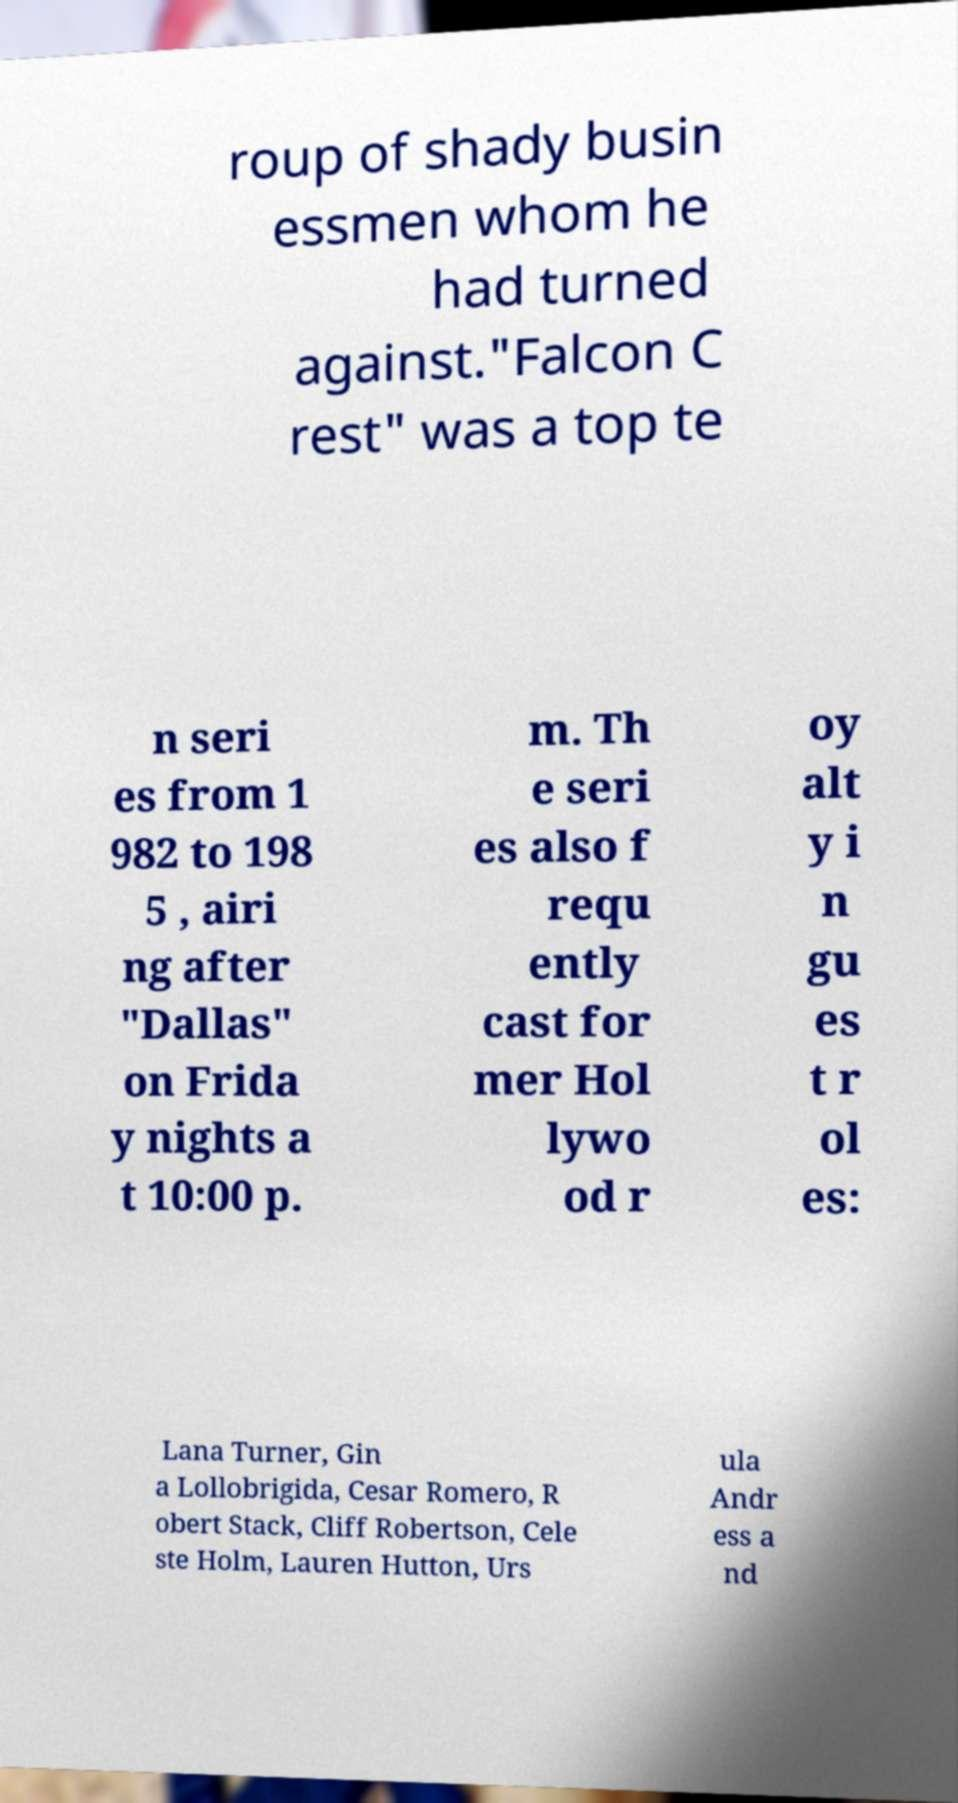Can you read and provide the text displayed in the image?This photo seems to have some interesting text. Can you extract and type it out for me? roup of shady busin essmen whom he had turned against."Falcon C rest" was a top te n seri es from 1 982 to 198 5 , airi ng after "Dallas" on Frida y nights a t 10:00 p. m. Th e seri es also f requ ently cast for mer Hol lywo od r oy alt y i n gu es t r ol es: Lana Turner, Gin a Lollobrigida, Cesar Romero, R obert Stack, Cliff Robertson, Cele ste Holm, Lauren Hutton, Urs ula Andr ess a nd 